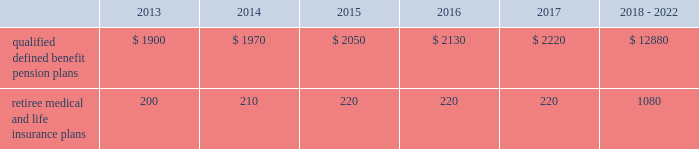Valuation techniques 2013 cash equivalents are mostly comprised of short-term money-market instruments and are valued at cost , which approximates fair value .
U.s .
Equity securities and international equity securities categorized as level 1 are traded on active national and international exchanges and are valued at their closing prices on the last trading day of the year .
For u.s .
Equity securities and international equity securities not traded on an active exchange , or if the closing price is not available , the trustee obtains indicative quotes from a pricing vendor , broker , or investment manager .
These securities are categorized as level 2 if the custodian obtains corroborated quotes from a pricing vendor or categorized as level 3 if the custodian obtains uncorroborated quotes from a broker or investment manager .
Commingled equity funds are public investment vehicles valued using the net asset value ( nav ) provided by the fund manager .
The nav is the total value of the fund divided by the number of shares outstanding .
Commingled equity funds are categorized as level 1 if traded at their nav on a nationally recognized securities exchange or categorized as level 2 if the nav is corroborated by observable market data ( e.g. , purchases or sales activity ) .
Fixed income securities categorized as level 2 are valued by the trustee using pricing models that use verifiable observable market data ( e.g .
Interest rates and yield curves observable at commonly quoted intervals ) , bids provided by brokers or dealers , or quoted prices of securities with similar characteristics .
Private equity funds , real estate funds , hedge funds , and fixed income securities categorized as level 3 are valued based on valuation models that include significant unobservable inputs and cannot be corroborated using verifiable observable market data .
Valuations for private equity funds and real estate funds are determined by the general partners , while hedge funds are valued by independent administrators .
Depending on the nature of the assets , the general partners or independent administrators use both the income and market approaches in their models .
The market approach consists of analyzing market transactions for comparable assets while the income approach uses earnings or the net present value of estimated future cash flows adjusted for liquidity and other risk factors .
Commodities categorized as level 1 are traded on an active commodity exchange and are valued at their closing prices on the last trading day of the year .
Commodities categorized as level 2 represent shares in a commingled commodity fund valued using the nav , which is corroborated by observable market data .
Contributions and expected benefit payments we generally determine funding requirements for our defined benefit pension plans in a manner consistent with cas and internal revenue code rules .
In 2012 , we made contributions of $ 3.6 billion related to our qualified defined benefit pension plans .
We plan to make contributions of approximately $ 1.5 billion related to the qualified defined benefit pension plans in 2013 .
In 2012 , we made contributions of $ 235 million related to our retiree medical and life insurance plans .
We expect no required contributions related to the retiree medical and life insurance plans in 2013 .
The table presents estimated future benefit payments , which reflect expected future employee service , as of december 31 , 2012 ( in millions ) : .
Defined contribution plans we maintain a number of defined contribution plans , most with 401 ( k ) features , that cover substantially all of our employees .
Under the provisions of our 401 ( k ) plans , we match most employees 2019 eligible contributions at rates specified in the plan documents .
Our contributions were $ 380 million in 2012 , $ 378 million in 2011 , and $ 379 million in 2010 , the majority of which were funded in our common stock .
Our defined contribution plans held approximately 48.6 million and 52.1 million shares of our common stock as of december 31 , 2012 and 2011. .
What is the expected percentage change in contributions related to qualified defined benefit pension plans in 2013 compare to 2012? 
Computations: ((1.5 - 3.6) / 3.6)
Answer: -0.58333. 